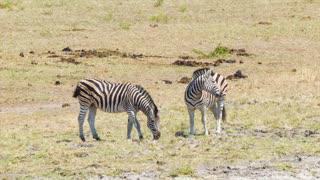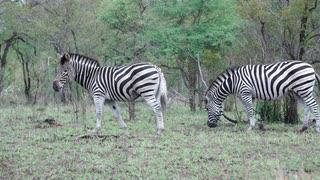The first image is the image on the left, the second image is the image on the right. Considering the images on both sides, is "Each image contains exactly two zebras, and at least one image features two zebras standing one in front of the other and facing the same direction." valid? Answer yes or no. Yes. The first image is the image on the left, the second image is the image on the right. Given the left and right images, does the statement "Two zebras are standing near each other in both pictures." hold true? Answer yes or no. Yes. 